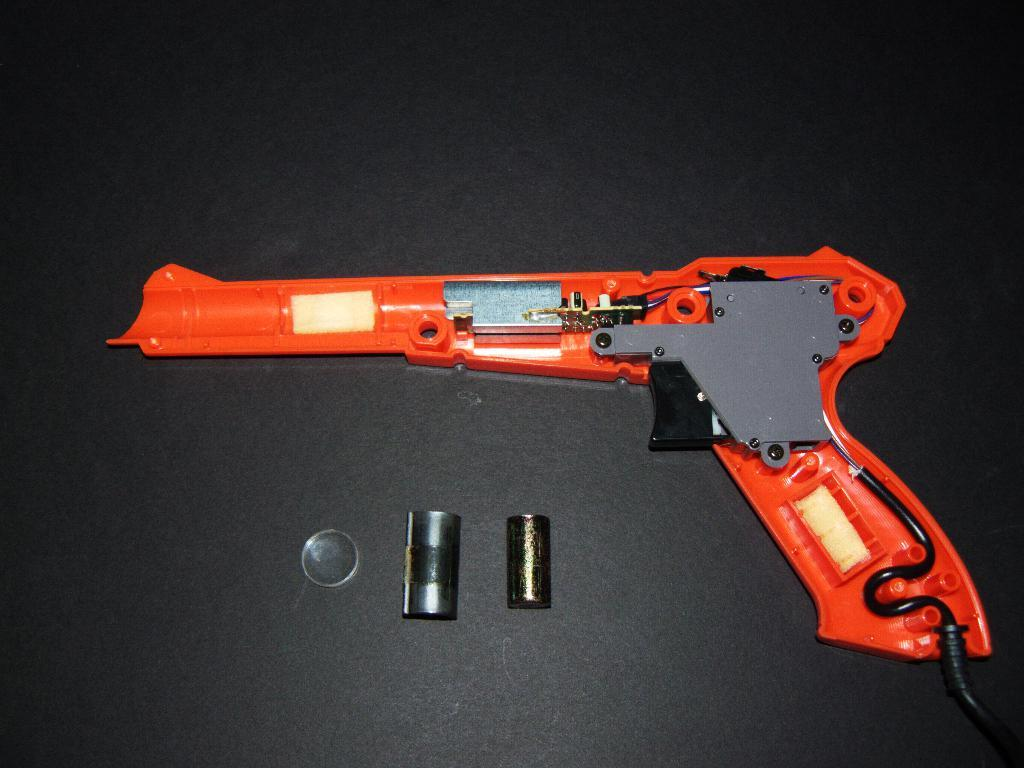What object is the main focus of the image? There is a gun in the image. What is the color of the gun? The gun is orange in color. What other items can be seen in the image? There are batteries visible in the image. What is the color of the background in the image? The background of the image is black. What hobbies does the brain depicted in the image enjoy? There is no brain present in the image, so it is not possible to determine any hobbies it might enjoy. 